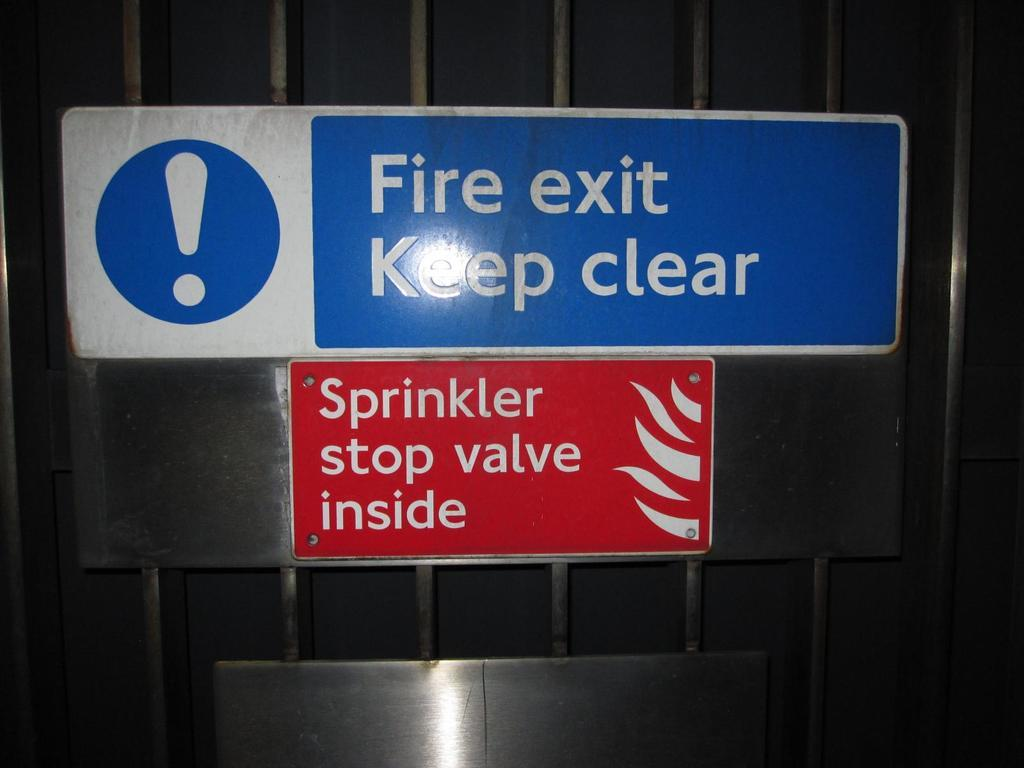<image>
Share a concise interpretation of the image provided. The Fire exit must be kept clear claims the blue and white sign with a big exclamation mark on it. 